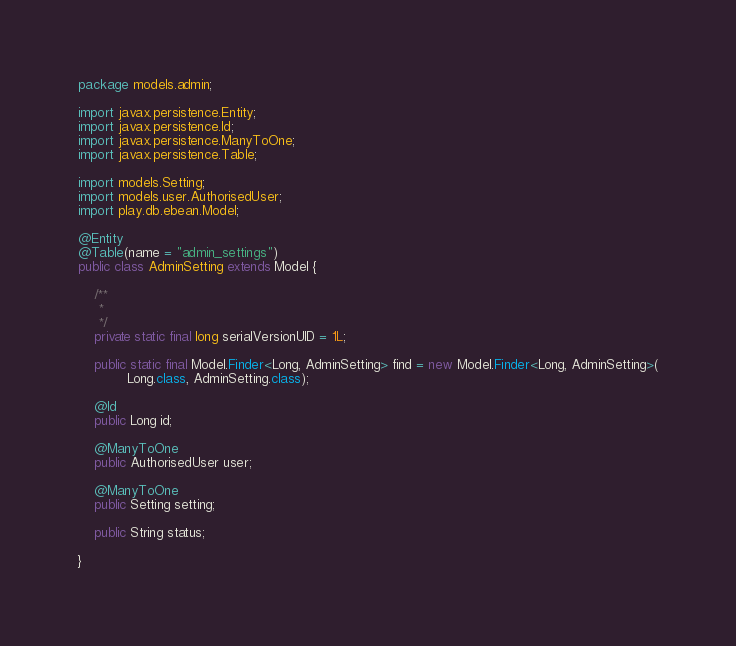Convert code to text. <code><loc_0><loc_0><loc_500><loc_500><_Java_>package models.admin;

import javax.persistence.Entity;
import javax.persistence.Id;
import javax.persistence.ManyToOne;
import javax.persistence.Table;

import models.Setting;
import models.user.AuthorisedUser;
import play.db.ebean.Model;

@Entity
@Table(name = "admin_settings")
public class AdminSetting extends Model {

	/**
	 *
	 */
	private static final long serialVersionUID = 1L;

	public static final Model.Finder<Long, AdminSetting> find = new Model.Finder<Long, AdminSetting>(
			Long.class, AdminSetting.class);

	@Id
	public Long id;

	@ManyToOne
	public AuthorisedUser user;

	@ManyToOne
	public Setting setting;

	public String status;

}
</code> 